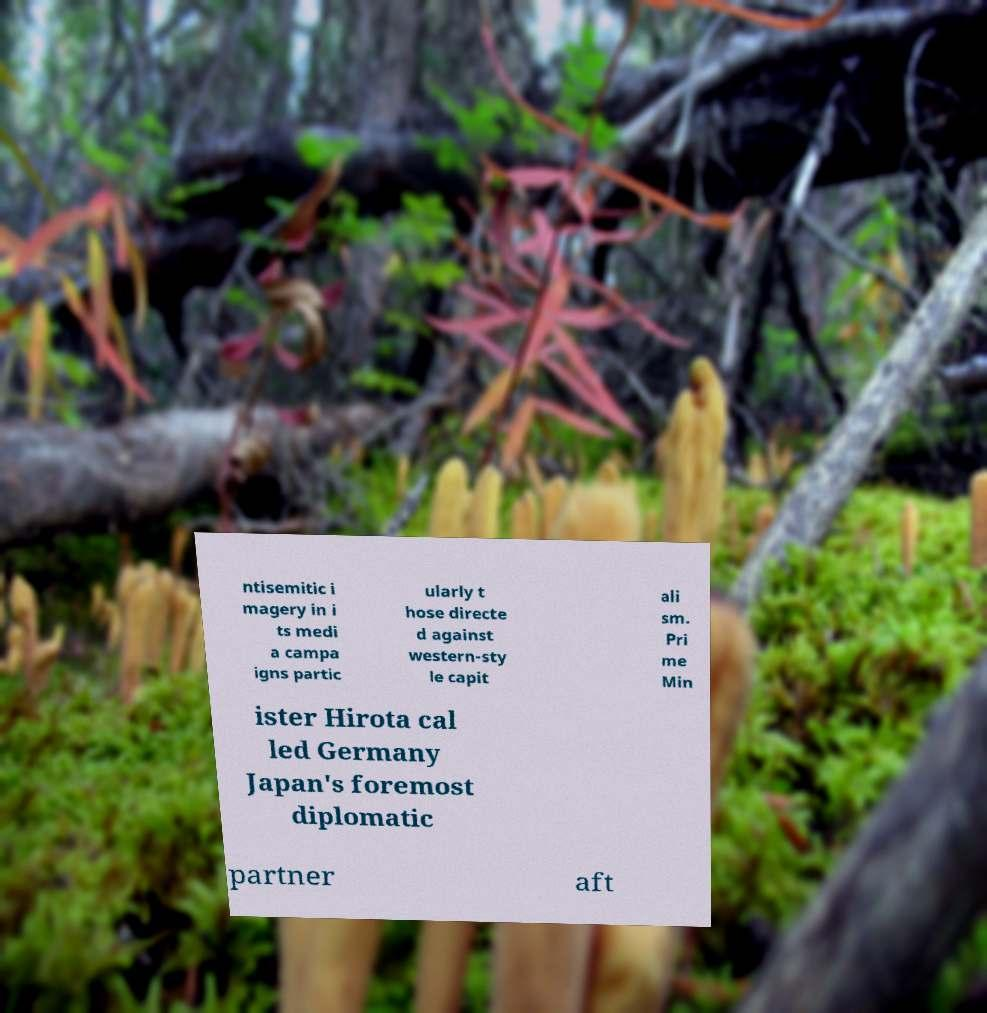There's text embedded in this image that I need extracted. Can you transcribe it verbatim? ntisemitic i magery in i ts medi a campa igns partic ularly t hose directe d against western-sty le capit ali sm. Pri me Min ister Hirota cal led Germany Japan's foremost diplomatic partner aft 